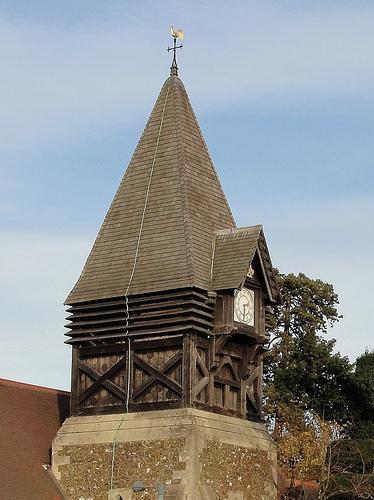How many clocks?
Give a very brief answer. 1. 